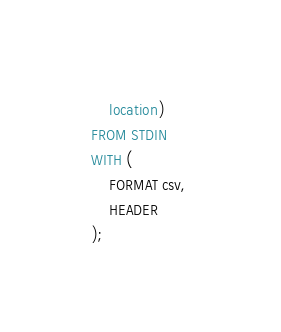Convert code to text. <code><loc_0><loc_0><loc_500><loc_500><_SQL_>    location)
FROM STDIN
WITH (
    FORMAT csv, 
    HEADER
);
</code> 